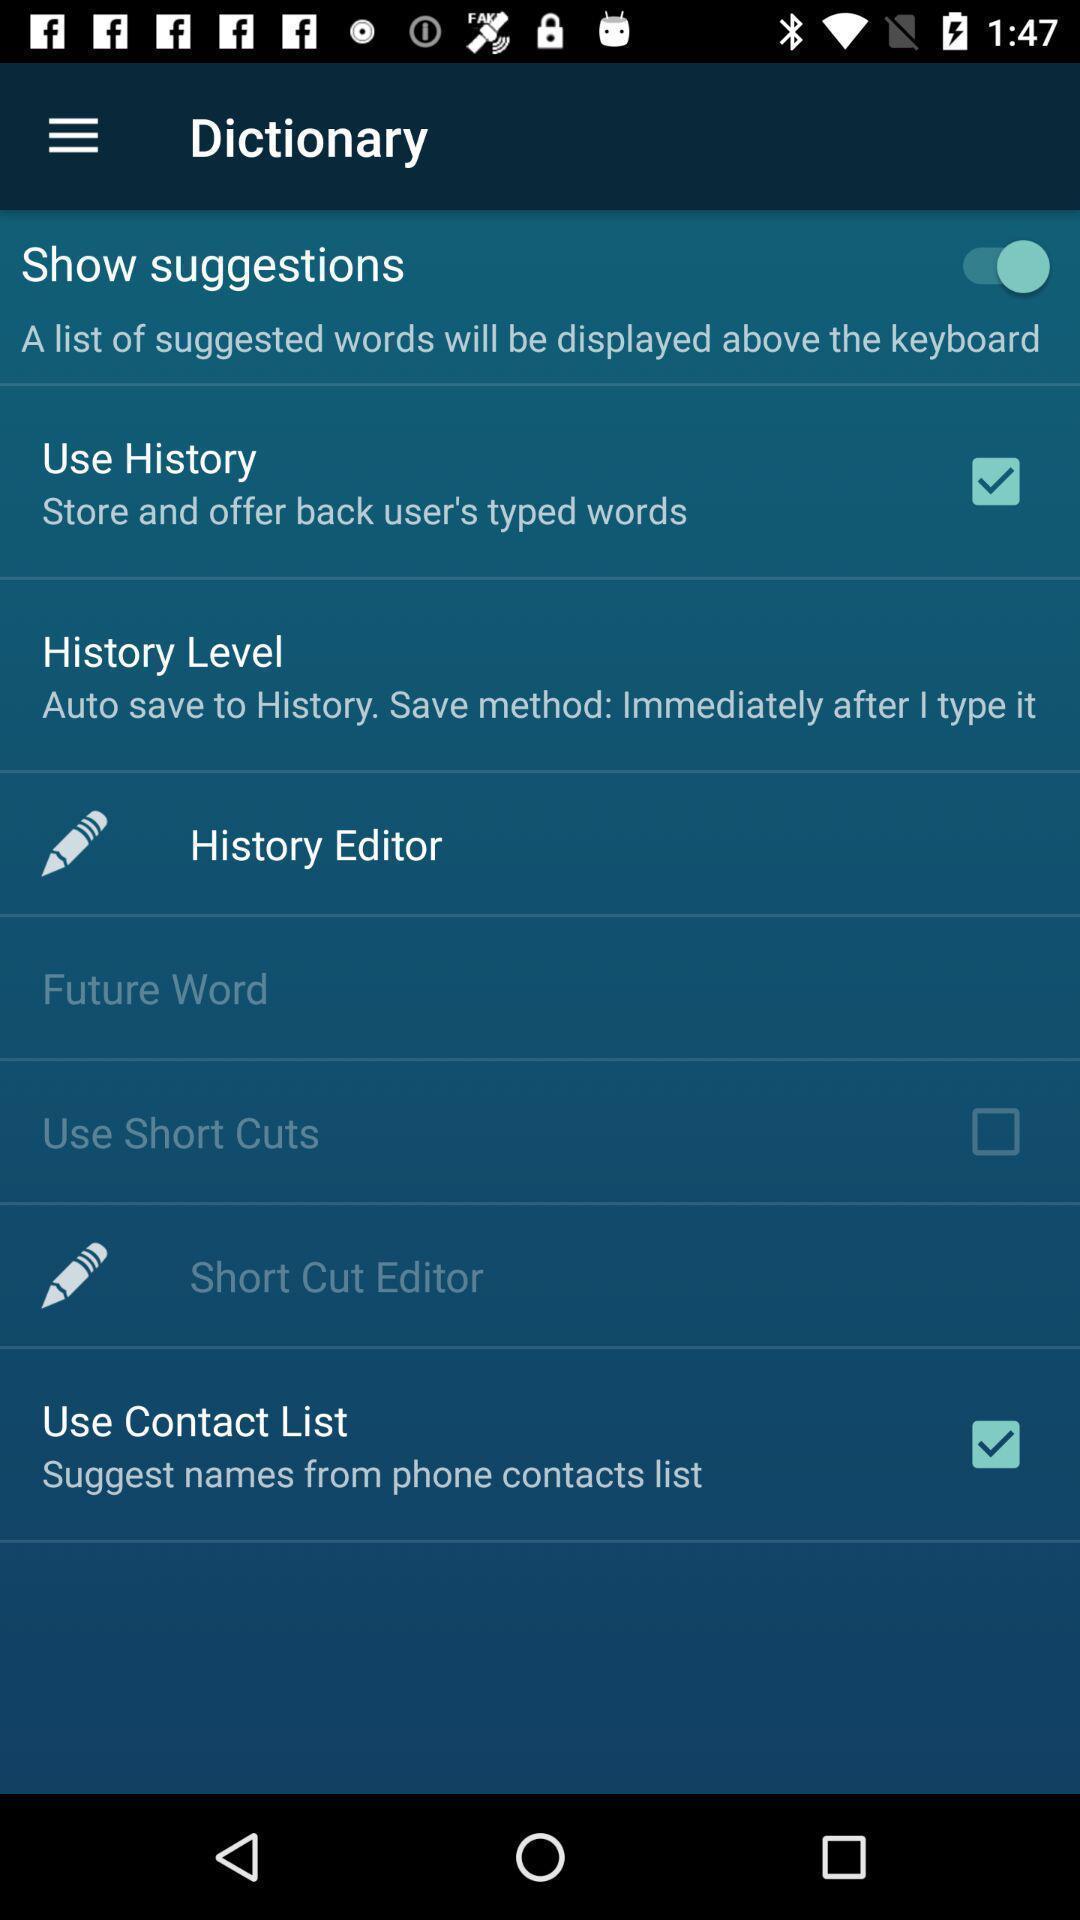Give me a narrative description of this picture. Page showing different setting options in language learning app. 